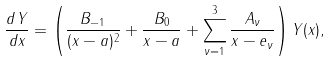Convert formula to latex. <formula><loc_0><loc_0><loc_500><loc_500>\frac { d Y } { d x } = \left ( \frac { B _ { - 1 } } { ( x - a ) ^ { 2 } } + \frac { B _ { 0 } } { x - a } + \sum _ { \nu = 1 } ^ { 3 } \frac { A _ { \nu } } { x - e _ { \nu } } \right ) Y ( x ) ,</formula> 